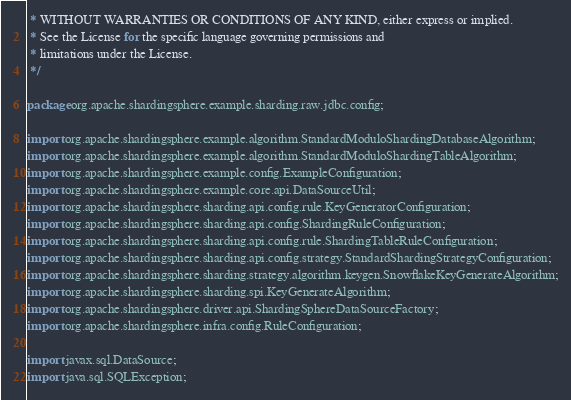<code> <loc_0><loc_0><loc_500><loc_500><_Java_> * WITHOUT WARRANTIES OR CONDITIONS OF ANY KIND, either express or implied.
 * See the License for the specific language governing permissions and
 * limitations under the License.
 */

package org.apache.shardingsphere.example.sharding.raw.jdbc.config;

import org.apache.shardingsphere.example.algorithm.StandardModuloShardingDatabaseAlgorithm;
import org.apache.shardingsphere.example.algorithm.StandardModuloShardingTableAlgorithm;
import org.apache.shardingsphere.example.config.ExampleConfiguration;
import org.apache.shardingsphere.example.core.api.DataSourceUtil;
import org.apache.shardingsphere.sharding.api.config.rule.KeyGeneratorConfiguration;
import org.apache.shardingsphere.sharding.api.config.ShardingRuleConfiguration;
import org.apache.shardingsphere.sharding.api.config.rule.ShardingTableRuleConfiguration;
import org.apache.shardingsphere.sharding.api.config.strategy.StandardShardingStrategyConfiguration;
import org.apache.shardingsphere.sharding.strategy.algorithm.keygen.SnowflakeKeyGenerateAlgorithm;
import org.apache.shardingsphere.sharding.spi.KeyGenerateAlgorithm;
import org.apache.shardingsphere.driver.api.ShardingSphereDataSourceFactory;
import org.apache.shardingsphere.infra.config.RuleConfiguration;

import javax.sql.DataSource;
import java.sql.SQLException;</code> 